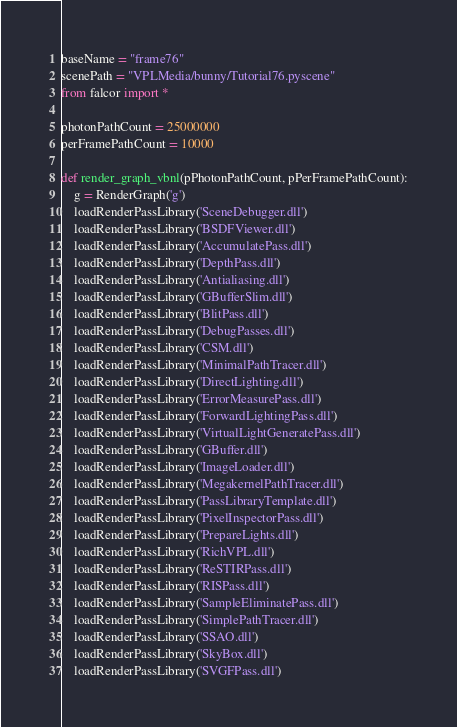<code> <loc_0><loc_0><loc_500><loc_500><_Python_>baseName = "frame76"
scenePath = "VPLMedia/bunny/Tutorial76.pyscene"
from falcor import *

photonPathCount = 25000000
perFramePathCount = 10000

def render_graph_vbnl(pPhotonPathCount, pPerFramePathCount):
    g = RenderGraph('g')
    loadRenderPassLibrary('SceneDebugger.dll')
    loadRenderPassLibrary('BSDFViewer.dll')
    loadRenderPassLibrary('AccumulatePass.dll')
    loadRenderPassLibrary('DepthPass.dll')
    loadRenderPassLibrary('Antialiasing.dll')
    loadRenderPassLibrary('GBufferSlim.dll')
    loadRenderPassLibrary('BlitPass.dll')
    loadRenderPassLibrary('DebugPasses.dll')
    loadRenderPassLibrary('CSM.dll')
    loadRenderPassLibrary('MinimalPathTracer.dll')
    loadRenderPassLibrary('DirectLighting.dll')
    loadRenderPassLibrary('ErrorMeasurePass.dll')
    loadRenderPassLibrary('ForwardLightingPass.dll')
    loadRenderPassLibrary('VirtualLightGeneratePass.dll')
    loadRenderPassLibrary('GBuffer.dll')
    loadRenderPassLibrary('ImageLoader.dll')
    loadRenderPassLibrary('MegakernelPathTracer.dll')
    loadRenderPassLibrary('PassLibraryTemplate.dll')
    loadRenderPassLibrary('PixelInspectorPass.dll')
    loadRenderPassLibrary('PrepareLights.dll')
    loadRenderPassLibrary('RichVPL.dll')
    loadRenderPassLibrary('ReSTIRPass.dll')
    loadRenderPassLibrary('RISPass.dll')
    loadRenderPassLibrary('SampleEliminatePass.dll')
    loadRenderPassLibrary('SimplePathTracer.dll')
    loadRenderPassLibrary('SSAO.dll')
    loadRenderPassLibrary('SkyBox.dll')
    loadRenderPassLibrary('SVGFPass.dll')</code> 